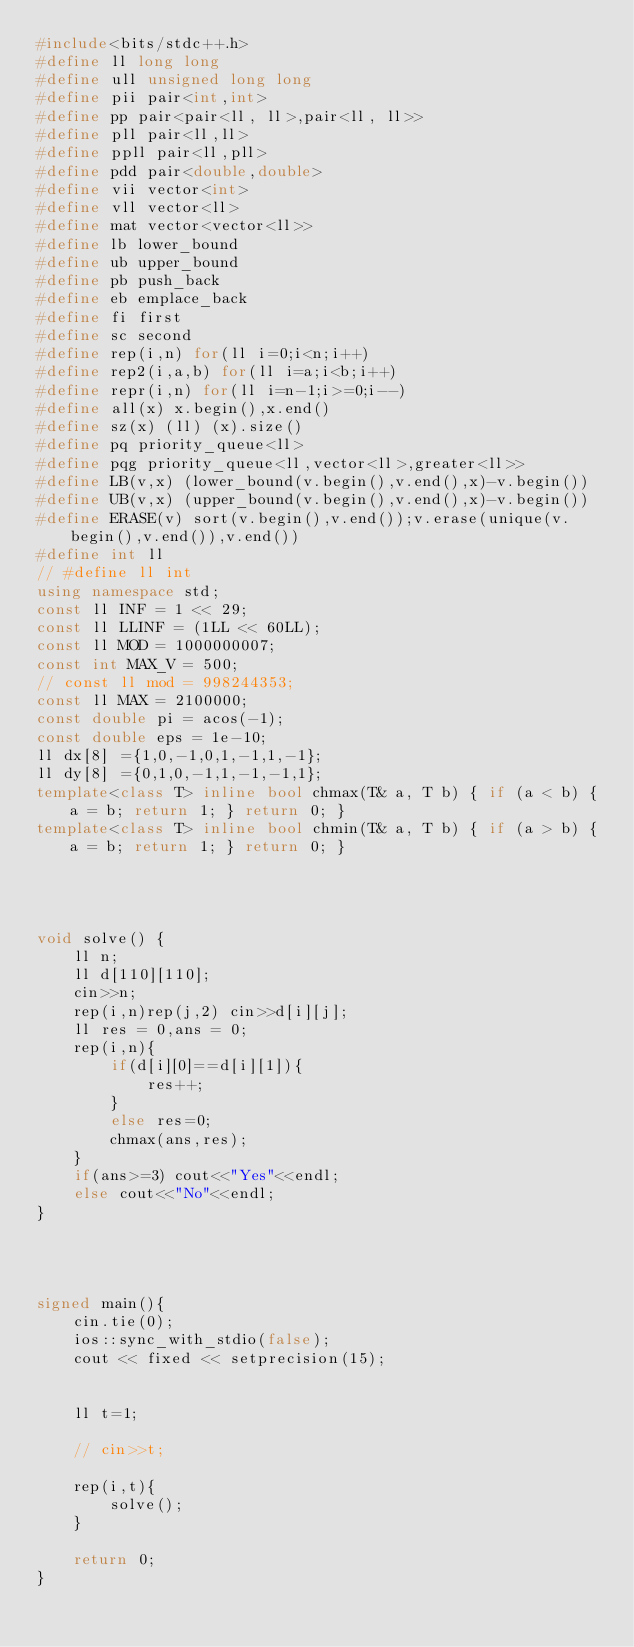Convert code to text. <code><loc_0><loc_0><loc_500><loc_500><_C++_>#include<bits/stdc++.h>
#define ll long long
#define ull unsigned long long
#define pii pair<int,int>
#define pp pair<pair<ll, ll>,pair<ll, ll>>
#define pll pair<ll,ll>
#define ppll pair<ll,pll>
#define pdd pair<double,double>
#define vii vector<int>
#define vll vector<ll>
#define mat vector<vector<ll>>
#define lb lower_bound
#define ub upper_bound
#define pb push_back
#define eb emplace_back
#define fi first
#define sc second
#define rep(i,n) for(ll i=0;i<n;i++)
#define rep2(i,a,b) for(ll i=a;i<b;i++)
#define repr(i,n) for(ll i=n-1;i>=0;i--)
#define all(x) x.begin(),x.end()
#define sz(x) (ll) (x).size()
#define pq priority_queue<ll>
#define pqg priority_queue<ll,vector<ll>,greater<ll>>
#define LB(v,x) (lower_bound(v.begin(),v.end(),x)-v.begin())
#define UB(v,x) (upper_bound(v.begin(),v.end(),x)-v.begin())
#define ERASE(v) sort(v.begin(),v.end());v.erase(unique(v.begin(),v.end()),v.end())
#define int ll
// #define ll int
using namespace std;
const ll INF = 1 << 29;
const ll LLINF = (1LL << 60LL);
const ll MOD = 1000000007;
const int MAX_V = 500;
// const ll mod = 998244353;
const ll MAX = 2100000;
const double pi = acos(-1);
const double eps = 1e-10;
ll dx[8] ={1,0,-1,0,1,-1,1,-1};
ll dy[8] ={0,1,0,-1,1,-1,-1,1};
template<class T> inline bool chmax(T& a, T b) { if (a < b) { a = b; return 1; } return 0; }
template<class T> inline bool chmin(T& a, T b) { if (a > b) { a = b; return 1; } return 0; }




void solve() {
    ll n;
    ll d[110][110];
    cin>>n;
    rep(i,n)rep(j,2) cin>>d[i][j];
    ll res = 0,ans = 0;
    rep(i,n){
        if(d[i][0]==d[i][1]){
            res++;
        }
        else res=0;
        chmax(ans,res);
    }
    if(ans>=3) cout<<"Yes"<<endl;
    else cout<<"No"<<endl;
}




signed main(){
    cin.tie(0);
    ios::sync_with_stdio(false);
    cout << fixed << setprecision(15);


    ll t=1;
    
    // cin>>t;

    rep(i,t){
        solve(); 
    }

    return 0;
}
</code> 